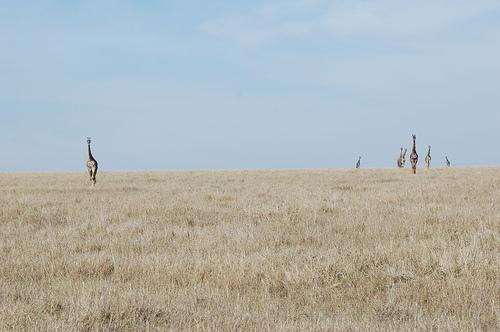What color is the grass?
Be succinct. Brown. How many blades of dry grass are there in the field?
Concise answer only. 1000. Can you see a tree?
Answer briefly. No. How many giraffes are pictured here?
Answer briefly. 7. What keeps the animals from getting close to the camera?
Be succinct. Nothing. 